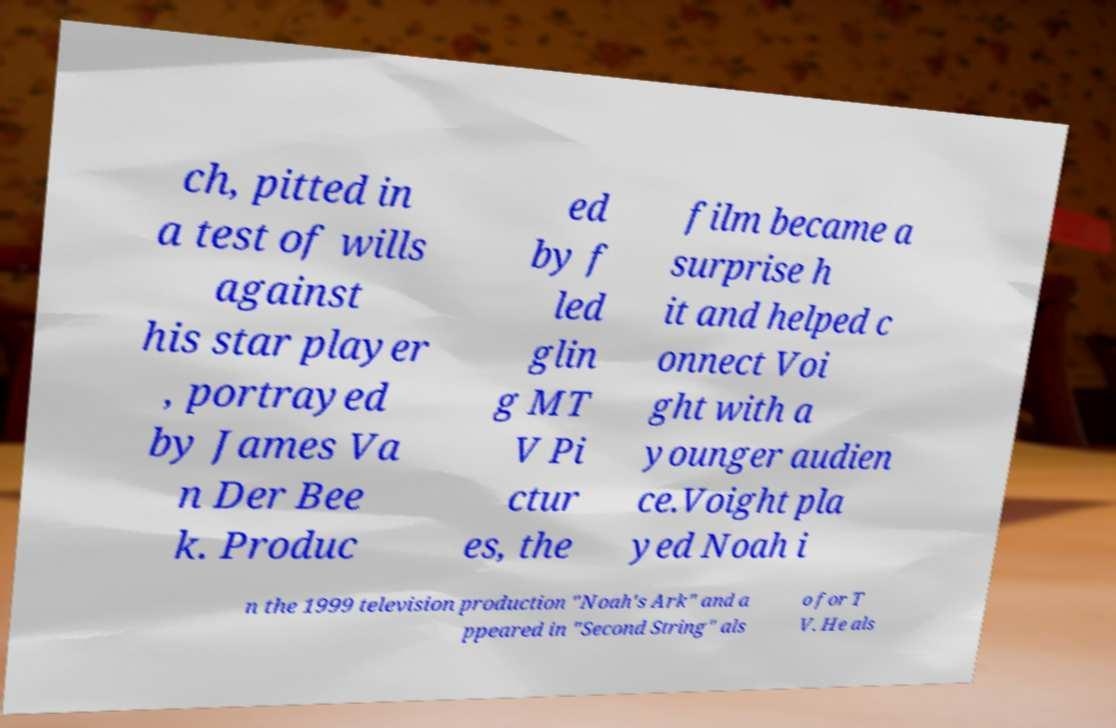I need the written content from this picture converted into text. Can you do that? ch, pitted in a test of wills against his star player , portrayed by James Va n Der Bee k. Produc ed by f led glin g MT V Pi ctur es, the film became a surprise h it and helped c onnect Voi ght with a younger audien ce.Voight pla yed Noah i n the 1999 television production "Noah's Ark" and a ppeared in "Second String" als o for T V. He als 